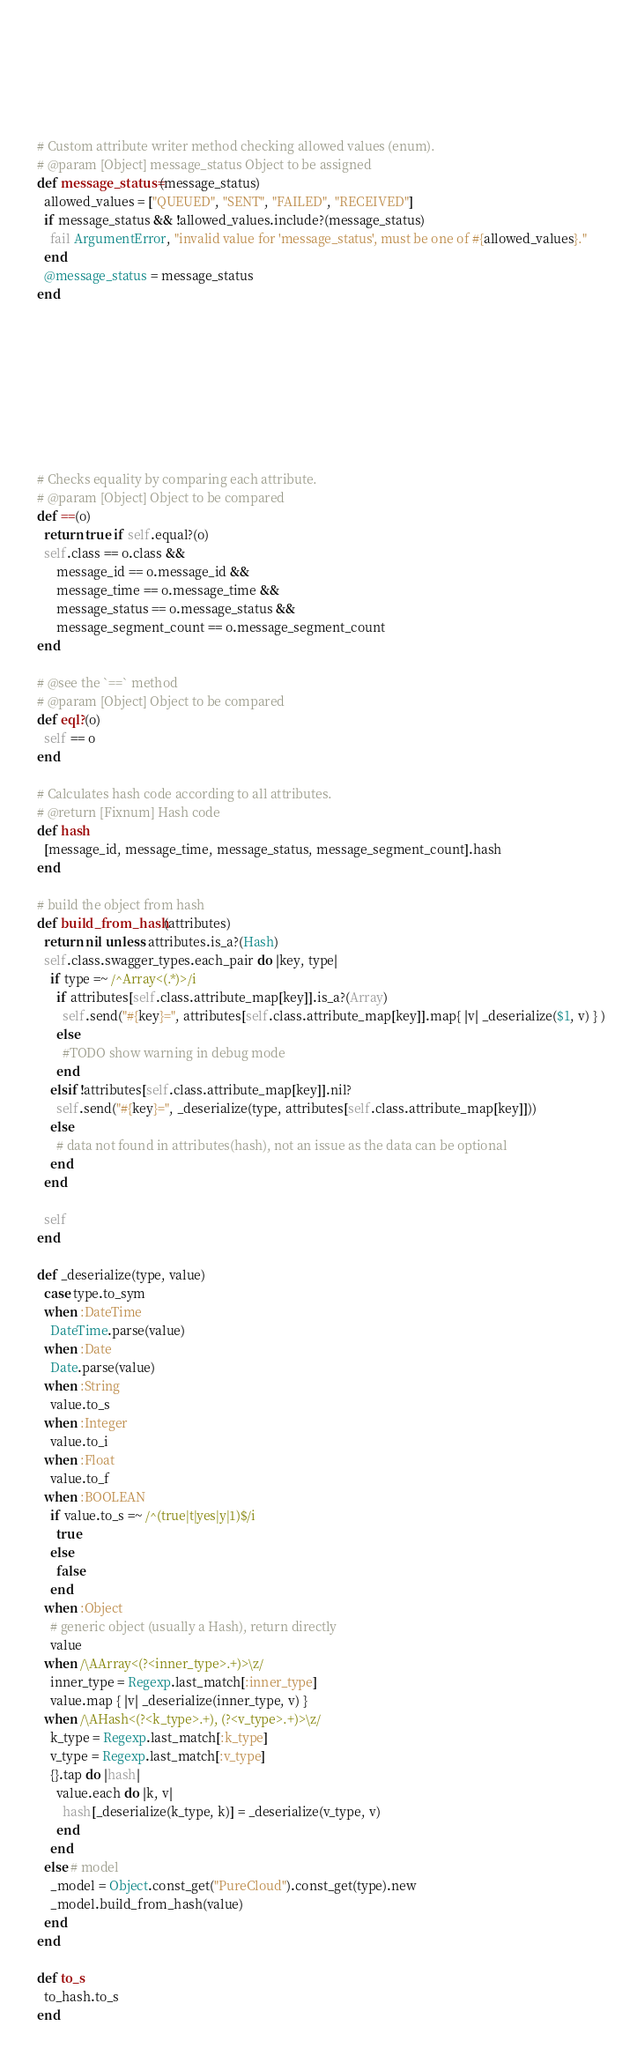<code> <loc_0><loc_0><loc_500><loc_500><_Ruby_>    
    
    
    
    
    
    # Custom attribute writer method checking allowed values (enum).
    # @param [Object] message_status Object to be assigned
    def message_status=(message_status)
      allowed_values = ["QUEUED", "SENT", "FAILED", "RECEIVED"]
      if message_status && !allowed_values.include?(message_status)
        fail ArgumentError, "invalid value for 'message_status', must be one of #{allowed_values}."
      end
      @message_status = message_status
    end

    
    
    
    
    
    
    
    
    # Checks equality by comparing each attribute.
    # @param [Object] Object to be compared
    def ==(o)
      return true if self.equal?(o)
      self.class == o.class &&
          message_id == o.message_id &&
          message_time == o.message_time &&
          message_status == o.message_status &&
          message_segment_count == o.message_segment_count
    end

    # @see the `==` method
    # @param [Object] Object to be compared
    def eql?(o)
      self == o
    end

    # Calculates hash code according to all attributes.
    # @return [Fixnum] Hash code
    def hash
      [message_id, message_time, message_status, message_segment_count].hash
    end

    # build the object from hash
    def build_from_hash(attributes)
      return nil unless attributes.is_a?(Hash)
      self.class.swagger_types.each_pair do |key, type|
        if type =~ /^Array<(.*)>/i
          if attributes[self.class.attribute_map[key]].is_a?(Array)
            self.send("#{key}=", attributes[self.class.attribute_map[key]].map{ |v| _deserialize($1, v) } )
          else
            #TODO show warning in debug mode
          end
        elsif !attributes[self.class.attribute_map[key]].nil?
          self.send("#{key}=", _deserialize(type, attributes[self.class.attribute_map[key]]))
        else
          # data not found in attributes(hash), not an issue as the data can be optional
        end
      end

      self
    end

    def _deserialize(type, value)
      case type.to_sym
      when :DateTime
        DateTime.parse(value)
      when :Date
        Date.parse(value)
      when :String
        value.to_s
      when :Integer
        value.to_i
      when :Float
        value.to_f
      when :BOOLEAN
        if value.to_s =~ /^(true|t|yes|y|1)$/i
          true
        else
          false
        end
      when :Object
        # generic object (usually a Hash), return directly
        value
      when /\AArray<(?<inner_type>.+)>\z/
        inner_type = Regexp.last_match[:inner_type]
        value.map { |v| _deserialize(inner_type, v) }
      when /\AHash<(?<k_type>.+), (?<v_type>.+)>\z/
        k_type = Regexp.last_match[:k_type]
        v_type = Regexp.last_match[:v_type]
        {}.tap do |hash|
          value.each do |k, v|
            hash[_deserialize(k_type, k)] = _deserialize(v_type, v)
          end
        end
      else # model
        _model = Object.const_get("PureCloud").const_get(type).new
        _model.build_from_hash(value)
      end
    end

    def to_s
      to_hash.to_s
    end
</code> 